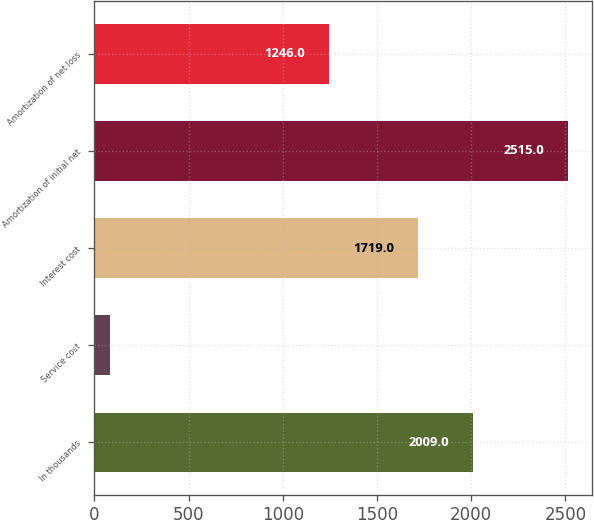Convert chart to OTSL. <chart><loc_0><loc_0><loc_500><loc_500><bar_chart><fcel>In thousands<fcel>Service cost<fcel>Interest cost<fcel>Amortization of initial net<fcel>Amortization of net loss<nl><fcel>2009<fcel>84<fcel>1719<fcel>2515<fcel>1246<nl></chart> 